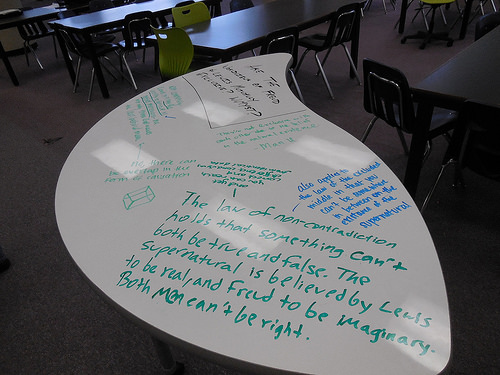<image>
Is the chair above the table? No. The chair is not positioned above the table. The vertical arrangement shows a different relationship. 